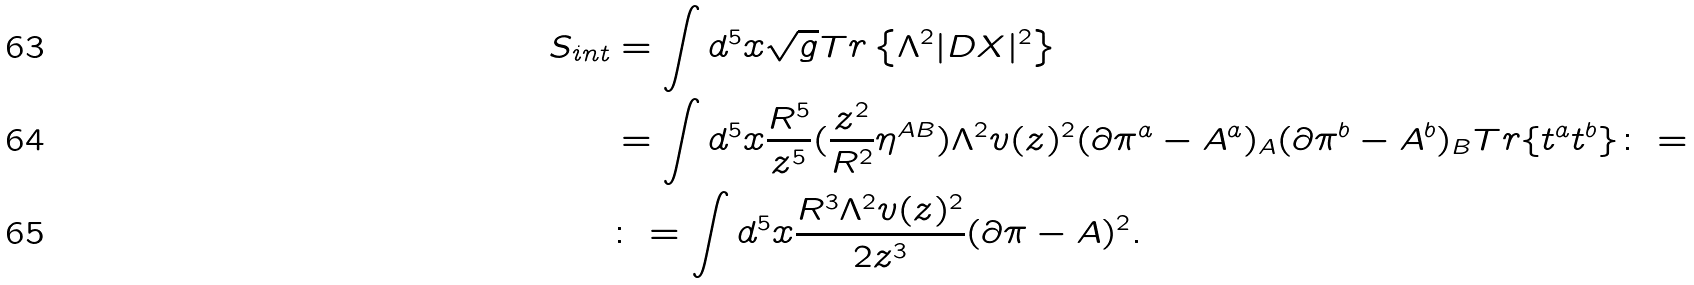<formula> <loc_0><loc_0><loc_500><loc_500>S _ { i n t } & = \int d ^ { 5 } x \sqrt { g } T r \left \{ \Lambda ^ { 2 } | D X | ^ { 2 } \right \} \\ & = \int d ^ { 5 } x \frac { R ^ { 5 } } { z ^ { 5 } } ( \frac { z ^ { 2 } } { R ^ { 2 } } \eta ^ { A B } ) \Lambda ^ { 2 } v ( z ) ^ { 2 } ( \partial \pi ^ { a } - A ^ { a } ) _ { A } ( \partial \pi ^ { b } - A ^ { b } ) _ { B } T r \{ t ^ { a } t ^ { b } \} \colon = \\ & \colon = \int d ^ { 5 } x \frac { R ^ { 3 } \Lambda ^ { 2 } v ( z ) ^ { 2 } } { 2 z ^ { 3 } } ( \partial \pi - A ) ^ { 2 } .</formula> 